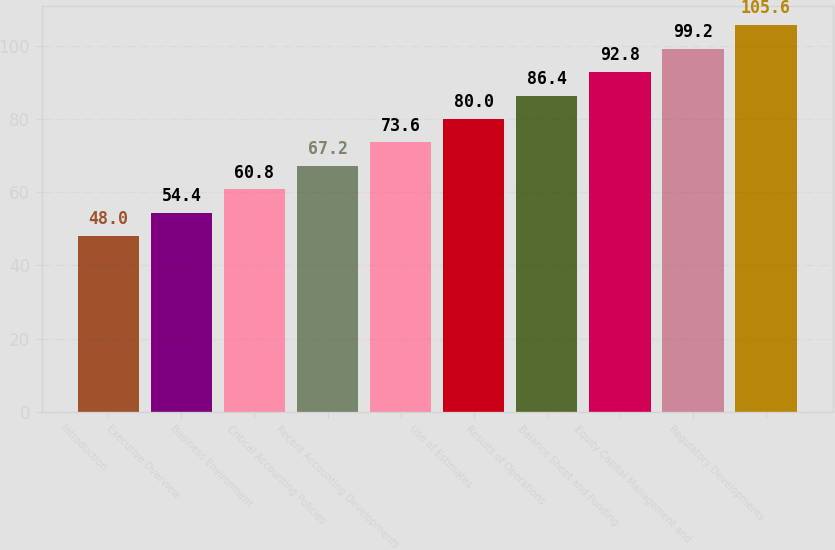Convert chart. <chart><loc_0><loc_0><loc_500><loc_500><bar_chart><fcel>Introduction<fcel>Executive Overview<fcel>Business Environment<fcel>Critical Accounting Policies<fcel>Recent Accounting Developments<fcel>Use of Estimates<fcel>Results of Operations<fcel>Balance Sheet and Funding<fcel>Equity Capital Management and<fcel>Regulatory Developments<nl><fcel>48<fcel>54.4<fcel>60.8<fcel>67.2<fcel>73.6<fcel>80<fcel>86.4<fcel>92.8<fcel>99.2<fcel>105.6<nl></chart> 